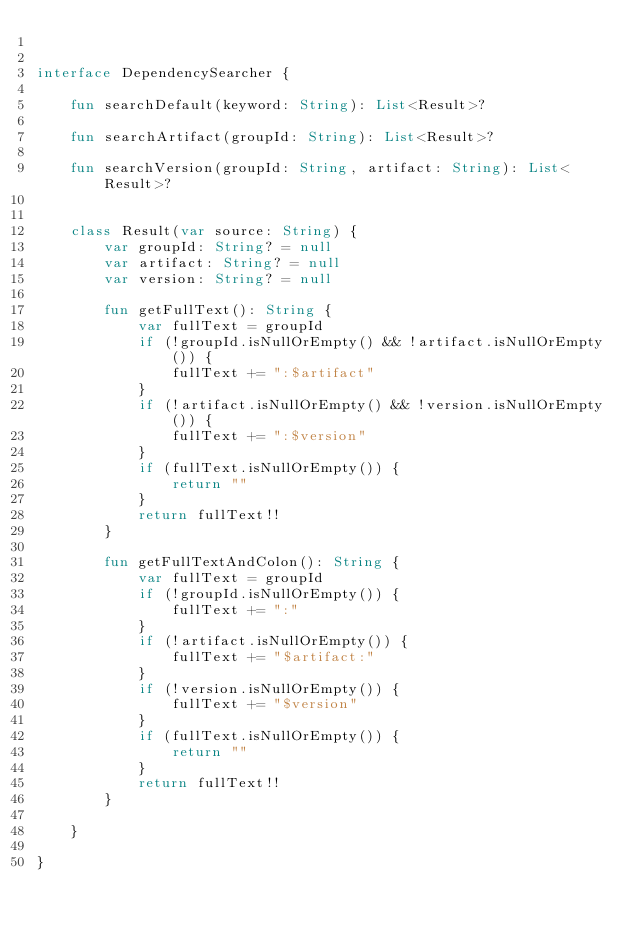Convert code to text. <code><loc_0><loc_0><loc_500><loc_500><_Kotlin_>

interface DependencySearcher {

    fun searchDefault(keyword: String): List<Result>?

    fun searchArtifact(groupId: String): List<Result>?

    fun searchVersion(groupId: String, artifact: String): List<Result>?


    class Result(var source: String) {
        var groupId: String? = null
        var artifact: String? = null
        var version: String? = null

        fun getFullText(): String {
            var fullText = groupId
            if (!groupId.isNullOrEmpty() && !artifact.isNullOrEmpty()) {
                fullText += ":$artifact"
            }
            if (!artifact.isNullOrEmpty() && !version.isNullOrEmpty()) {
                fullText += ":$version"
            }
            if (fullText.isNullOrEmpty()) {
                return ""
            }
            return fullText!!
        }

        fun getFullTextAndColon(): String {
            var fullText = groupId
            if (!groupId.isNullOrEmpty()) {
                fullText += ":"
            }
            if (!artifact.isNullOrEmpty()) {
                fullText += "$artifact:"
            }
            if (!version.isNullOrEmpty()) {
                fullText += "$version"
            }
            if (fullText.isNullOrEmpty()) {
                return ""
            }
            return fullText!!
        }

    }

}</code> 